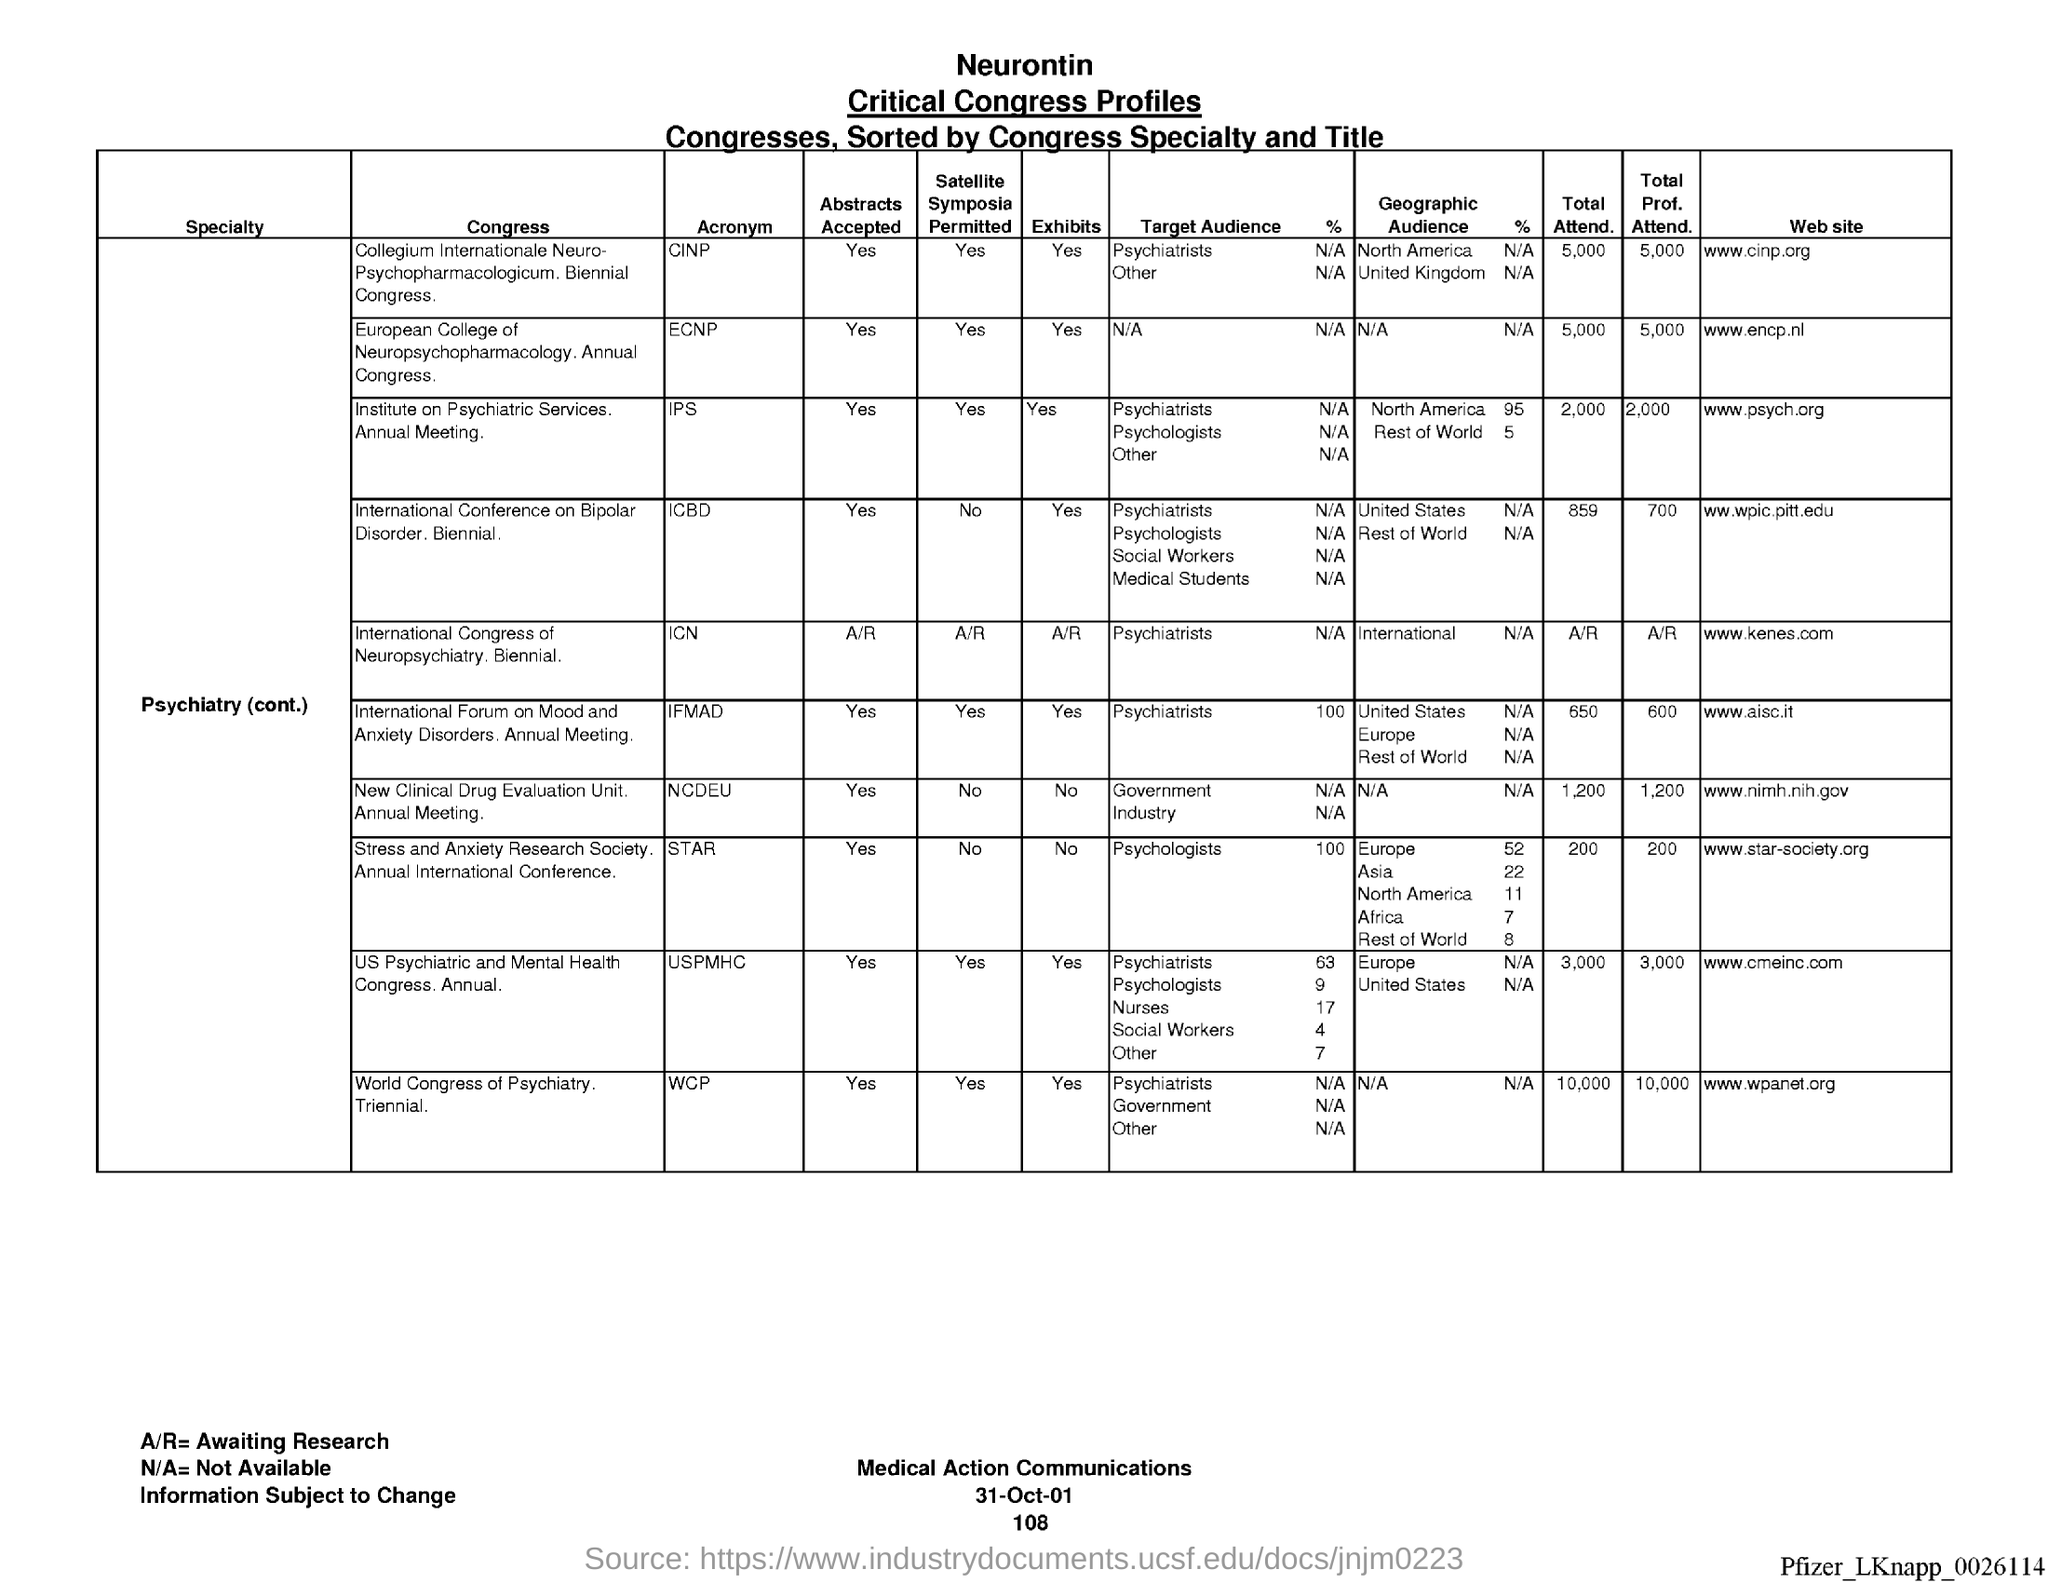What type of profiles is shown in the table ?
Ensure brevity in your answer.  Nerontin  Critical Congress Profiles. What is the first Column heading given?
Make the answer very short. Specialty. Mention the "website" given for "Collegium Internationale Neuro-Psychopharmacologicum" Congress?
Your response must be concise. Www.cinp.org. Mention the "Acronym" given for "Collegium Internationale Neuro-Psychopharmacologicum" Congress?
Your answer should be compact. CINP. Mention the "Total Attend." given for "Collegium Internationale Neuro-Psychopharmacologicum" Congress?
Provide a succinct answer. 5,000. Mention the "Total Prof. Attend." given for "Collegium Internationale Neuro-Psychopharmacologicum" Congress?
Provide a succinct answer. 5,000. Mention the "Acronym" given for "International Congress of Neuropsychiatry"?
Offer a terse response. ICN. 